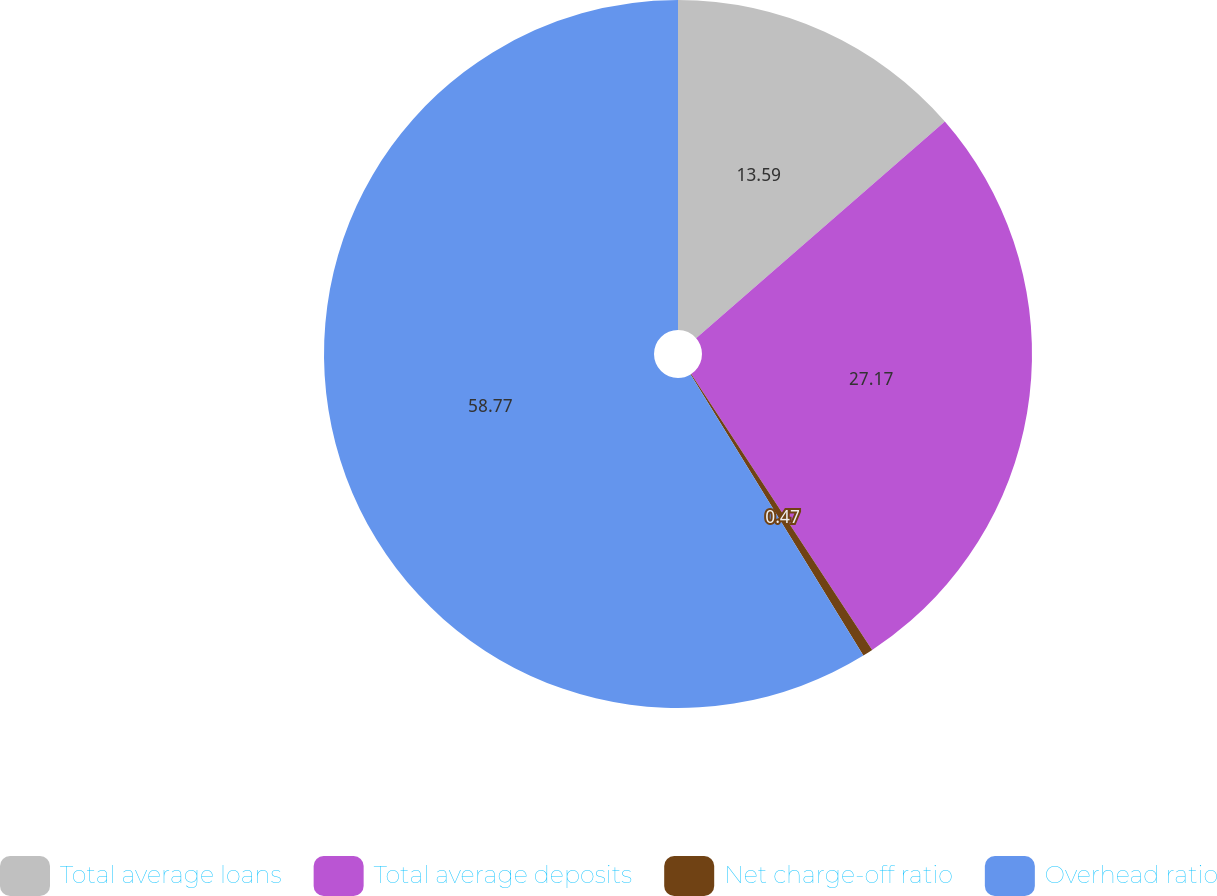<chart> <loc_0><loc_0><loc_500><loc_500><pie_chart><fcel>Total average loans<fcel>Total average deposits<fcel>Net charge-off ratio<fcel>Overhead ratio<nl><fcel>13.59%<fcel>27.17%<fcel>0.47%<fcel>58.77%<nl></chart> 